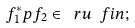<formula> <loc_0><loc_0><loc_500><loc_500>f _ { 1 } ^ { * } p f _ { 2 } \in \ r u \ f i n ;</formula> 